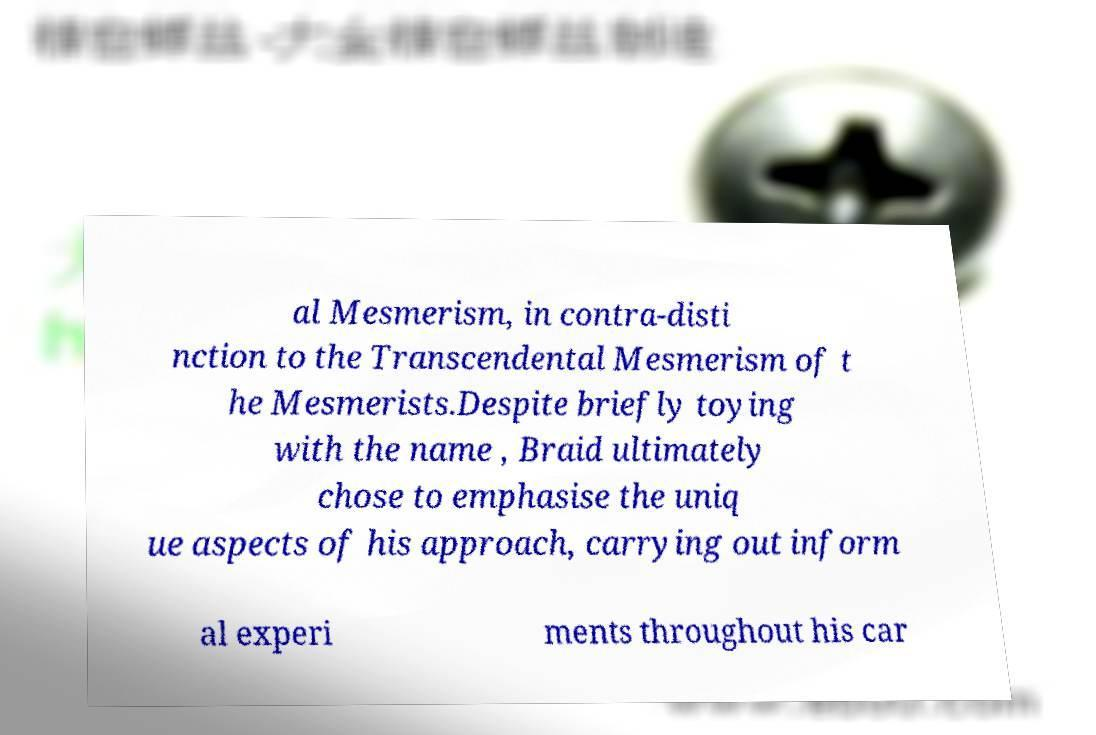For documentation purposes, I need the text within this image transcribed. Could you provide that? al Mesmerism, in contra-disti nction to the Transcendental Mesmerism of t he Mesmerists.Despite briefly toying with the name , Braid ultimately chose to emphasise the uniq ue aspects of his approach, carrying out inform al experi ments throughout his car 